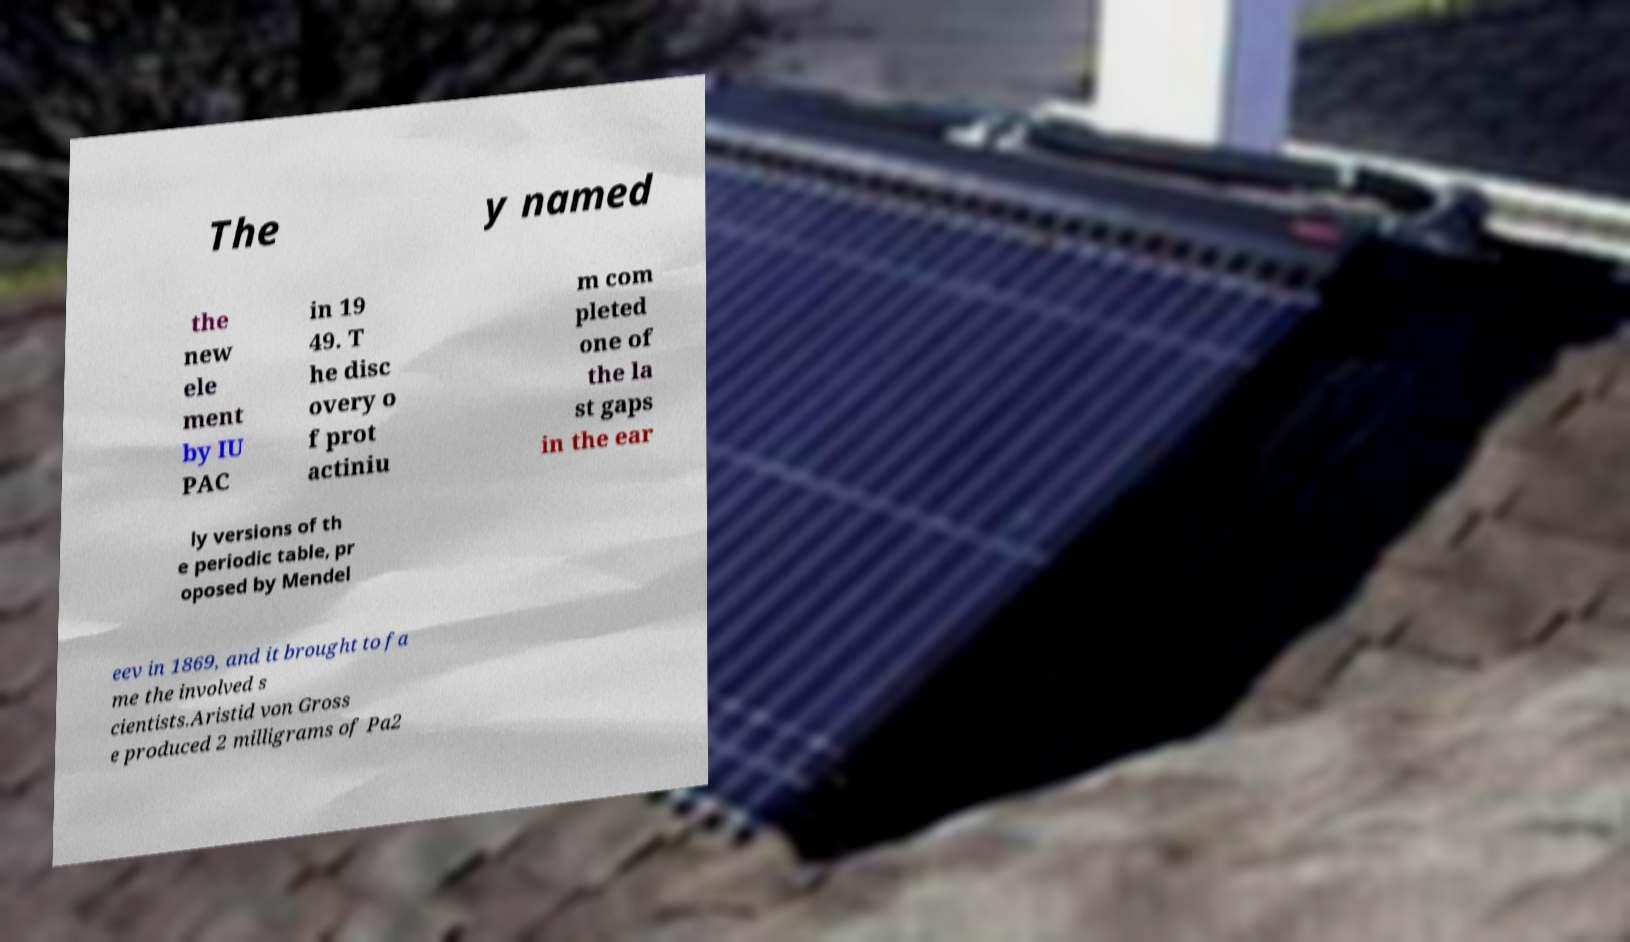Can you accurately transcribe the text from the provided image for me? The y named the new ele ment by IU PAC in 19 49. T he disc overy o f prot actiniu m com pleted one of the la st gaps in the ear ly versions of th e periodic table, pr oposed by Mendel eev in 1869, and it brought to fa me the involved s cientists.Aristid von Gross e produced 2 milligrams of Pa2 